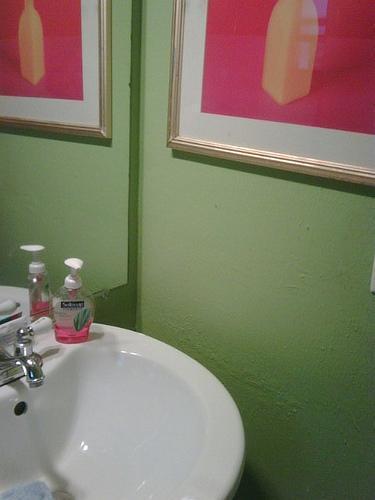How many faucets are shown?
Give a very brief answer. 1. How many sinks in the picture?
Give a very brief answer. 1. How many women are in the picture above the bears head?
Give a very brief answer. 0. 